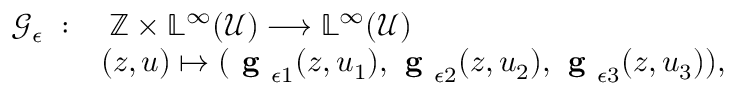Convert formula to latex. <formula><loc_0><loc_0><loc_500><loc_500>\begin{array} { r l } { \mathcal { G } _ { \epsilon } \, \colon } & { \, \mathbb { Z } \times \mathbb { L } ^ { \infty } ( \mathcal { U } ) \longrightarrow \mathbb { L } ^ { \infty } ( \mathcal { U } ) } \\ & { ( z , u ) \mapsto ( g _ { \epsilon 1 } ( z , u _ { 1 } ) , g _ { \epsilon 2 } ( z , u _ { 2 } ) , g _ { \epsilon 3 } ( z , u _ { 3 } ) ) , } \end{array}</formula> 